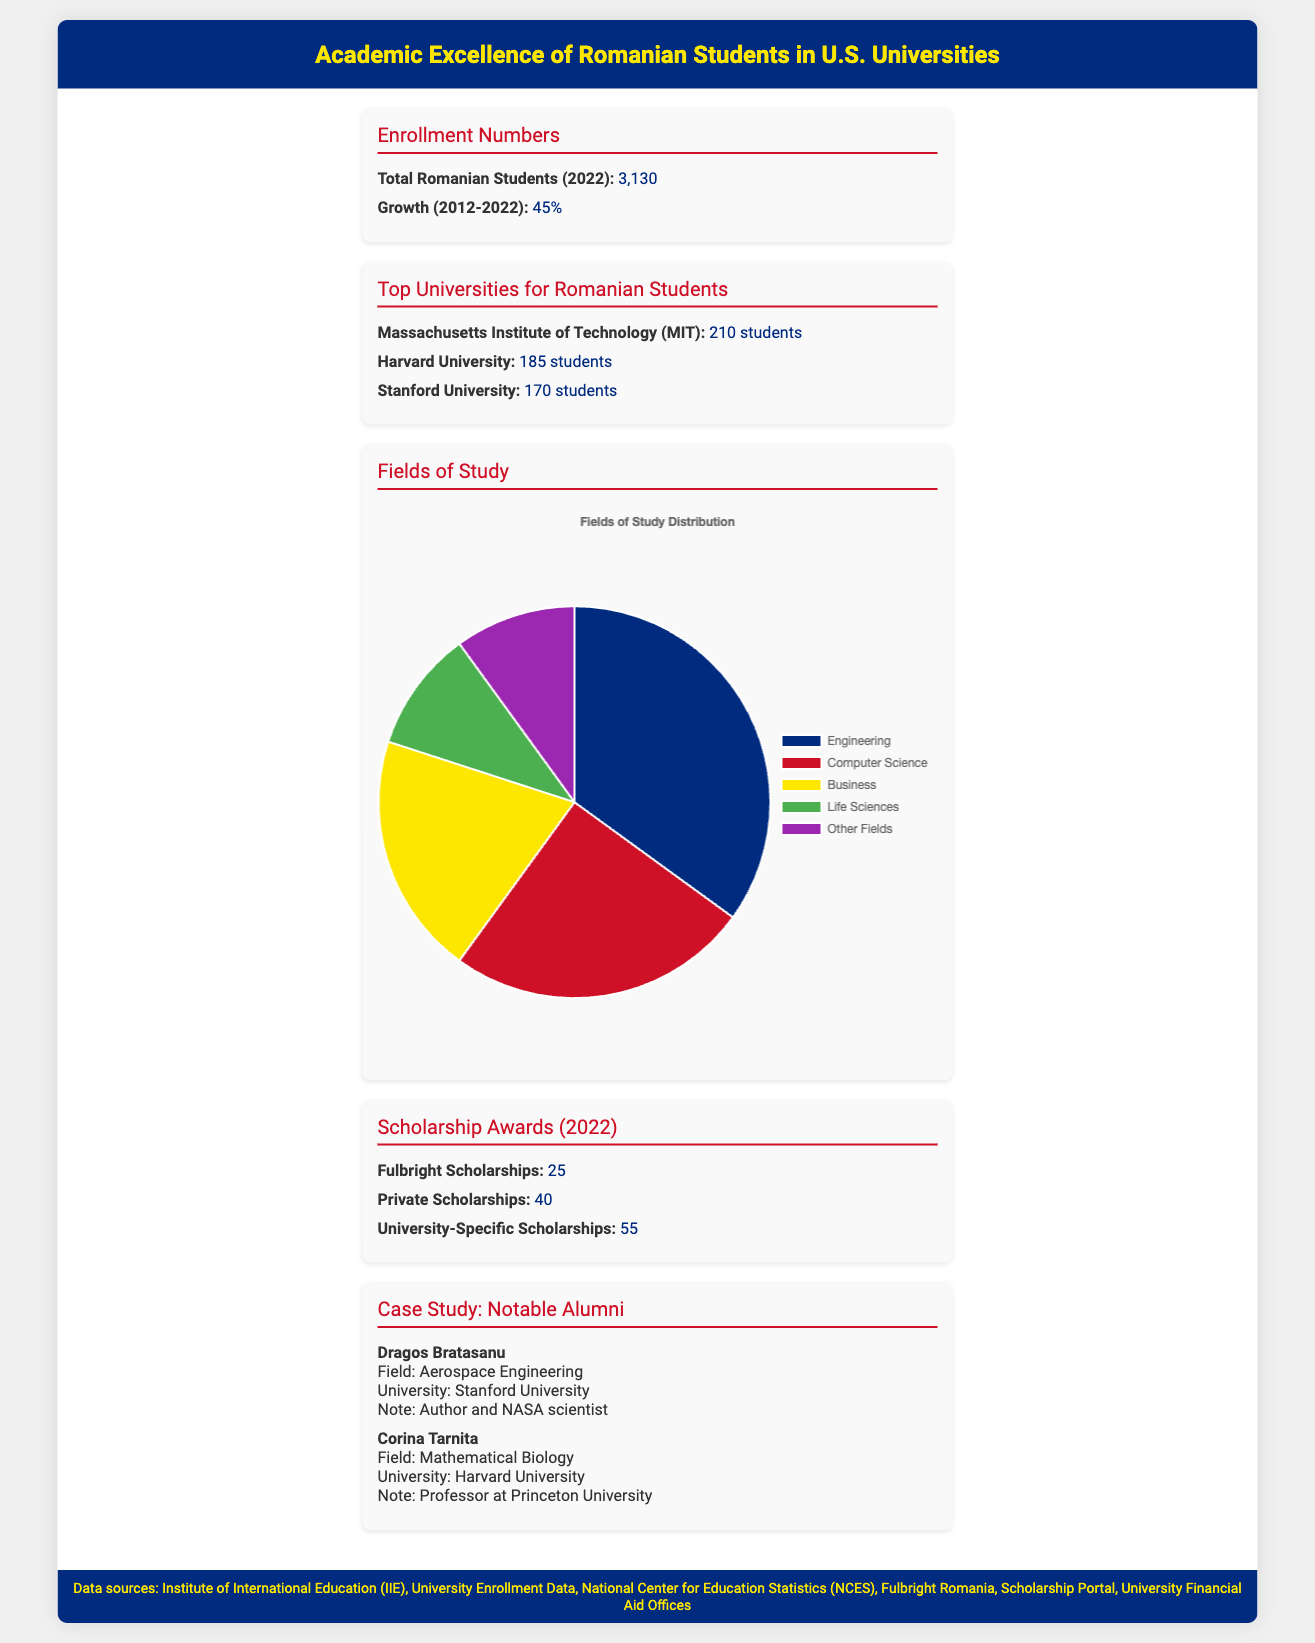What was the total enrollment of Romanian students in 2022? The total enrollment of Romanian students in 2022 is explicitly stated in the document as 3,130.
Answer: 3,130 What percentage did enrollment grow from 2012 to 2022? The document specifies a growth rate of 45% from 2012 to 2022, which is explicitly stated.
Answer: 45% Which university has the highest number of Romanian students? The section on top universities indicates that the Massachusetts Institute of Technology (MIT) has the highest number of Romanian students at 210.
Answer: Massachusetts Institute of Technology (MIT) How many Fulbright Scholarships were awarded to Romanian students in 2022? The scholarship data points out that there were 25 Fulbright Scholarships awarded in 2022.
Answer: 25 Which field of study has the highest percentage representation among Romanian students? The chart data shows that Engineering has the highest percentage representation, which is 35%.
Answer: Engineering Name a notable Romanian alumnus mentioned in the document. The case study section lists Dragos Bratasanu and Corina Tarnita as notable alumni of Romanian descent.
Answer: Dragos Bratasanu What color represents Computer Science in the study fields chart? The chart colors are defined, and Computer Science is represented by the color red (#CE1126) in the document.
Answer: Red How many university-specific scholarships were awarded in 2022? The document states that there were 55 university-specific scholarships awarded in 2022.
Answer: 55 Which field of study occupies the least amount of representation in the document? According to the chart, Life Sciences and Other Fields both occupy the least amount of representation, each at 10%.
Answer: Life Sciences and Other Fields 